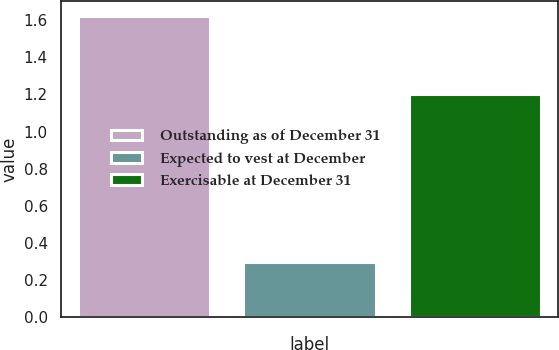<chart> <loc_0><loc_0><loc_500><loc_500><bar_chart><fcel>Outstanding as of December 31<fcel>Expected to vest at December<fcel>Exercisable at December 31<nl><fcel>1.62<fcel>0.3<fcel>1.2<nl></chart> 